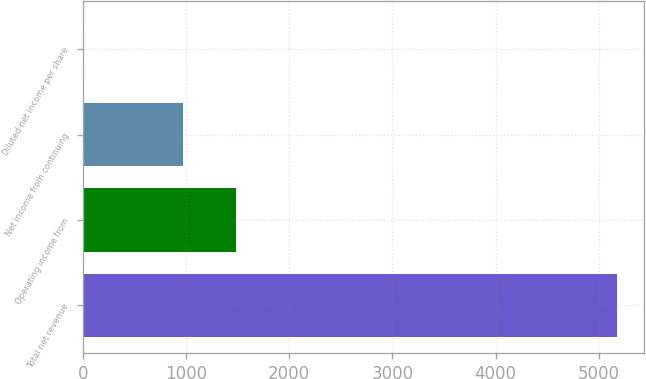Convert chart to OTSL. <chart><loc_0><loc_0><loc_500><loc_500><bar_chart><fcel>Total net revenue<fcel>Operating income from<fcel>Net income from continuing<fcel>Diluted net income per share<nl><fcel>5177<fcel>1488.33<fcel>971<fcel>3.72<nl></chart> 